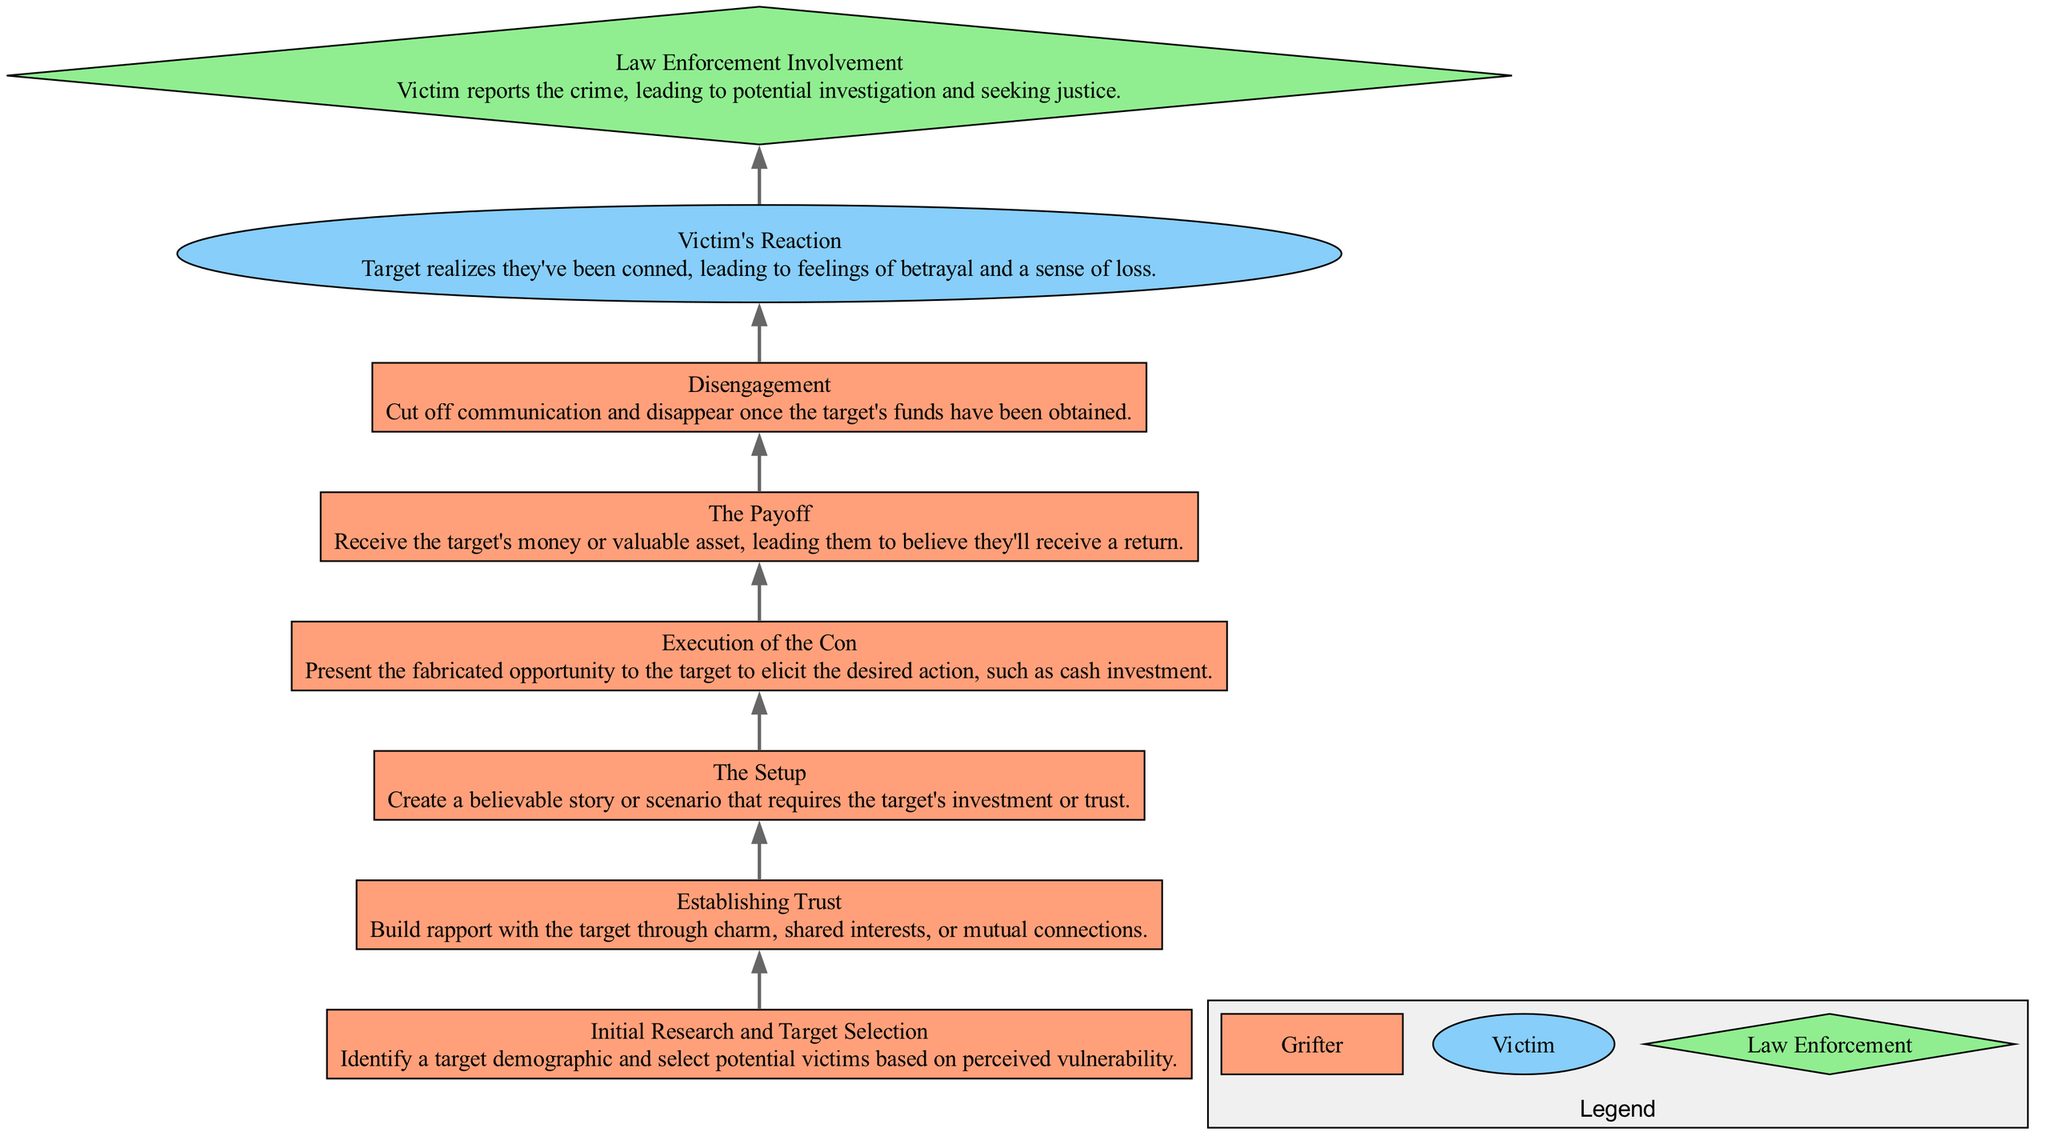What is the first step in the timeline? The first step mentioned in the timeline is "Initial Research and Target Selection." It is identified as the first node in the flow chart, making it the starting point of the process.
Answer: Initial Research and Target Selection How many nodes are there in total? Counting the nodes listed in the data, there are eight distinct elements outlining the steps in the process, which corresponds to the number of nodes in the flow chart.
Answer: 8 What role does "Law Enforcement Involvement" play in the flow chart? "Law Enforcement Involvement" is positioned towards the end of the flow chart and represents the role of authorities when a victim reports the crime. It's a distinct phase where intervention occurs.
Answer: Law Enforcement What connects "Execution of the Con" to "The Payoff"? These two nodes are connected directly by an edge, indicating that "Execution of the Con" logically leads to "The Payoff" as a consequence of successfully convincing the target.
Answer: An edge What is the reaction of the victim after realizing they've been conned? According to the flow chart, the victim's reaction is described as feelings of betrayal and a sense of loss, which is a common response when someone realizes they have been deceived.
Answer: Feelings of betrayal and a sense of loss What is the last step before disengagement? The node immediately preceding "Disengagement" is "The Payoff," indicating that after receiving the target's funds, the grifter prepares to cut off communication and disappear.
Answer: The Payoff Which role is linked with the last two steps of the diagram? The last two steps—"Victim's Reaction" and "Law Enforcement Involvement"—are linked to the role of the victim, who experiences the aftermath of the con and ultimately reports the crime to law enforcement.
Answer: Victim How does one step lead to the next in the diagram? The diagram flows from one step to the next with directed edges indicating the sequence of actions taken by the grifter, demonstrating a clear progression through each milestone.
Answer: Directed edges 